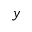<formula> <loc_0><loc_0><loc_500><loc_500>y</formula> 